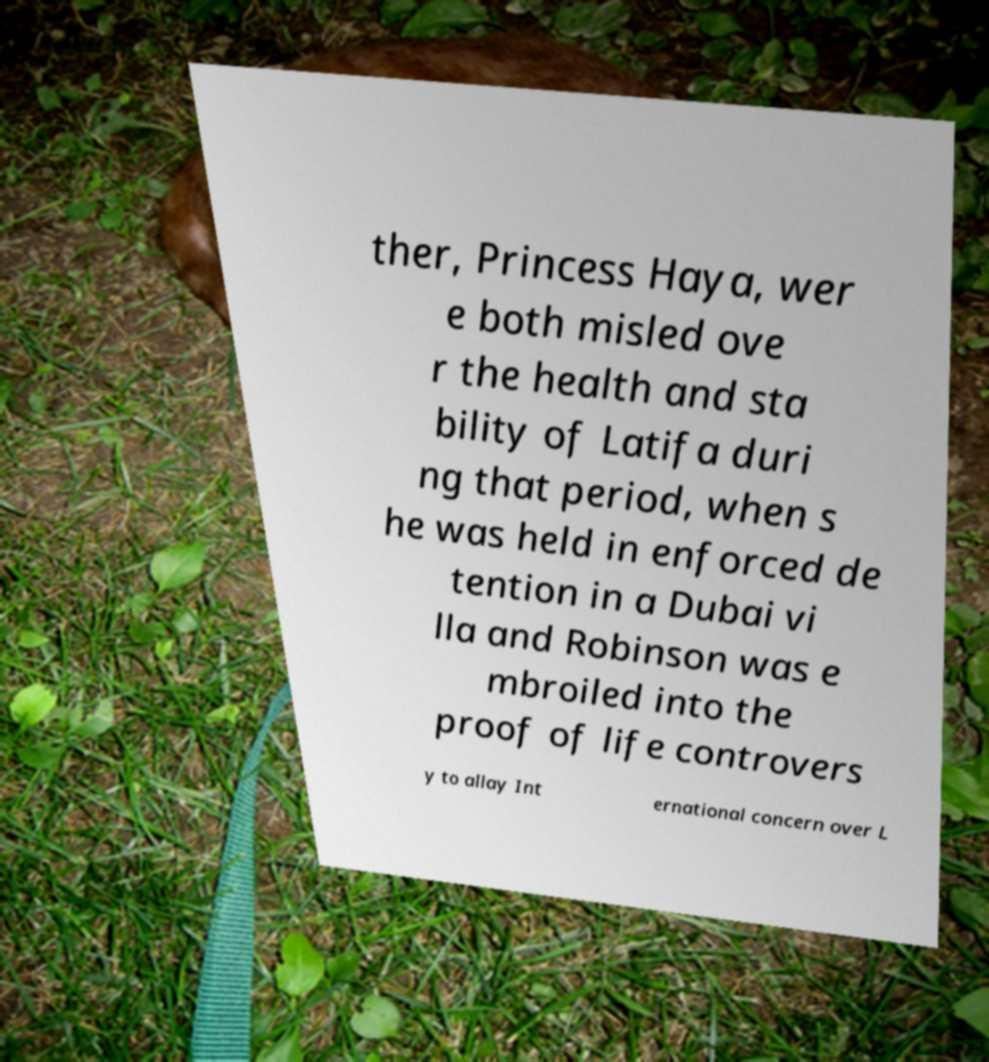Please identify and transcribe the text found in this image. ther, Princess Haya, wer e both misled ove r the health and sta bility of Latifa duri ng that period, when s he was held in enforced de tention in a Dubai vi lla and Robinson was e mbroiled into the proof of life controvers y to allay Int ernational concern over L 